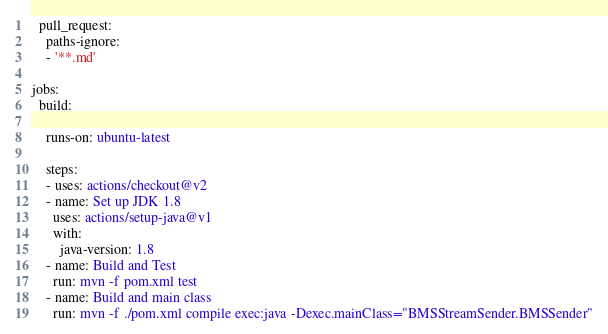<code> <loc_0><loc_0><loc_500><loc_500><_YAML_>  pull_request:
    paths-ignore:
    - '**.md'

jobs:
  build:

    runs-on: ubuntu-latest

    steps:
    - uses: actions/checkout@v2
    - name: Set up JDK 1.8
      uses: actions/setup-java@v1
      with:
        java-version: 1.8
    - name: Build and Test
      run: mvn -f pom.xml test
    - name: Build and main class
      run: mvn -f ./pom.xml compile exec:java -Dexec.mainClass="BMSStreamSender.BMSSender"</code> 